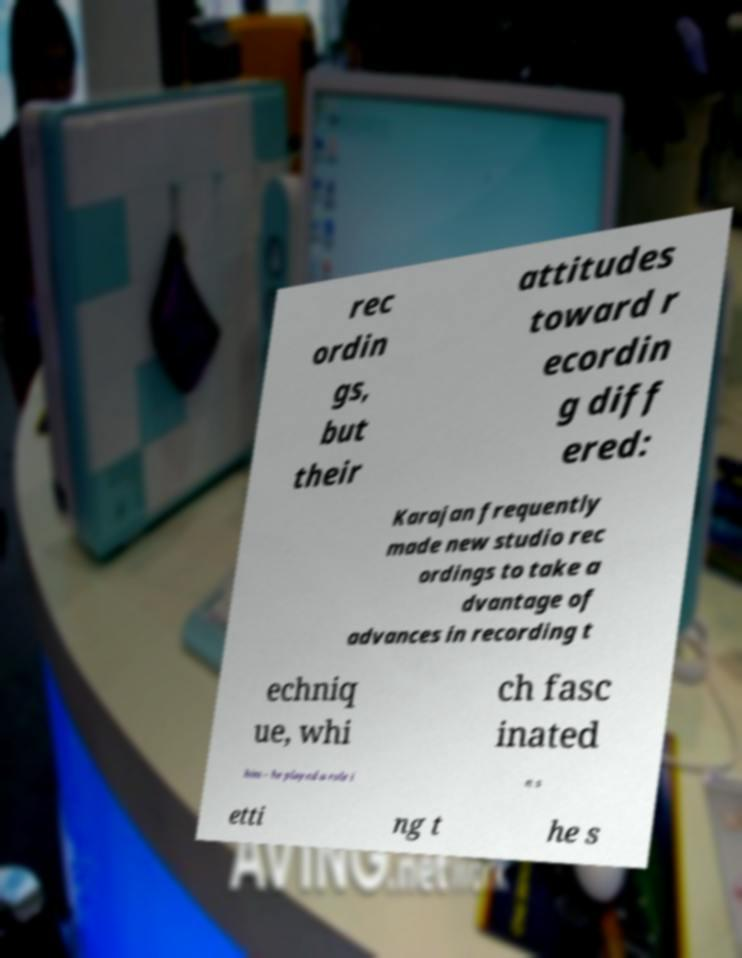Please identify and transcribe the text found in this image. rec ordin gs, but their attitudes toward r ecordin g diff ered: Karajan frequently made new studio rec ordings to take a dvantage of advances in recording t echniq ue, whi ch fasc inated him – he played a role i n s etti ng t he s 